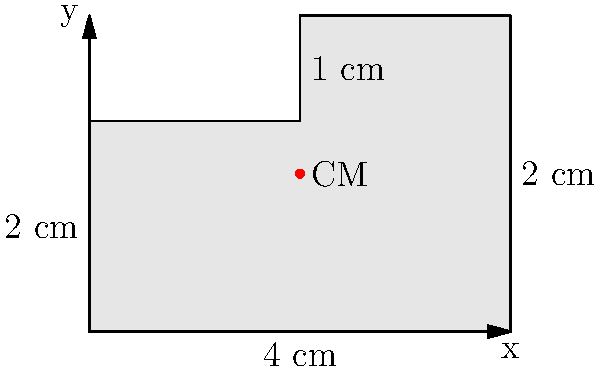In the game of chess, understanding balance and center of mass is crucial for piece placement. Consider the irregular shape shown in the diagram, which represents a custom chess piece. If the shape is made of a uniform material, determine the x-coordinate of its center of mass. All measurements are in centimeters. To find the x-coordinate of the center of mass for this irregular shape, we can follow these steps:

1) Divide the shape into two rectangles:
   Rectangle A: 4 cm x 2 cm
   Rectangle B: 2 cm x 1 cm

2) Calculate the areas of these rectangles:
   Area A = 4 * 2 = 8 cm²
   Area B = 2 * 1 = 2 cm²

3) Find the x-coordinate of the centroid for each rectangle:
   Rectangle A: x_A = 2 cm (midpoint of its width)
   Rectangle B: x_B = 3 cm (1 cm from the right edge)

4) Use the formula for the x-coordinate of the center of mass:

   $$ x_{CM} = \frac{\sum (A_i \cdot x_i)}{\sum A_i} $$

   Where $A_i$ is the area of each part and $x_i$ is the x-coordinate of its centroid.

5) Plug in the values:

   $$ x_{CM} = \frac{(8 \cdot 2) + (2 \cdot 3)}{8 + 2} = \frac{16 + 6}{10} = \frac{22}{10} = 2.2 \text{ cm} $$

Thus, the x-coordinate of the center of mass is 2.2 cm from the left edge of the shape.
Answer: 2.2 cm 